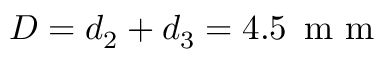<formula> <loc_0><loc_0><loc_500><loc_500>D = d _ { 2 } + d _ { 3 } = 4 . 5 \, m m</formula> 